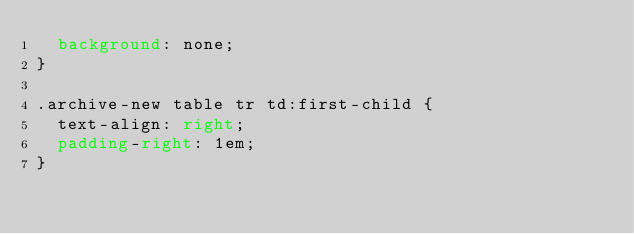<code> <loc_0><loc_0><loc_500><loc_500><_CSS_>	background: none;
}

.archive-new table tr td:first-child {
	text-align: right;
	padding-right: 1em;
}
</code> 